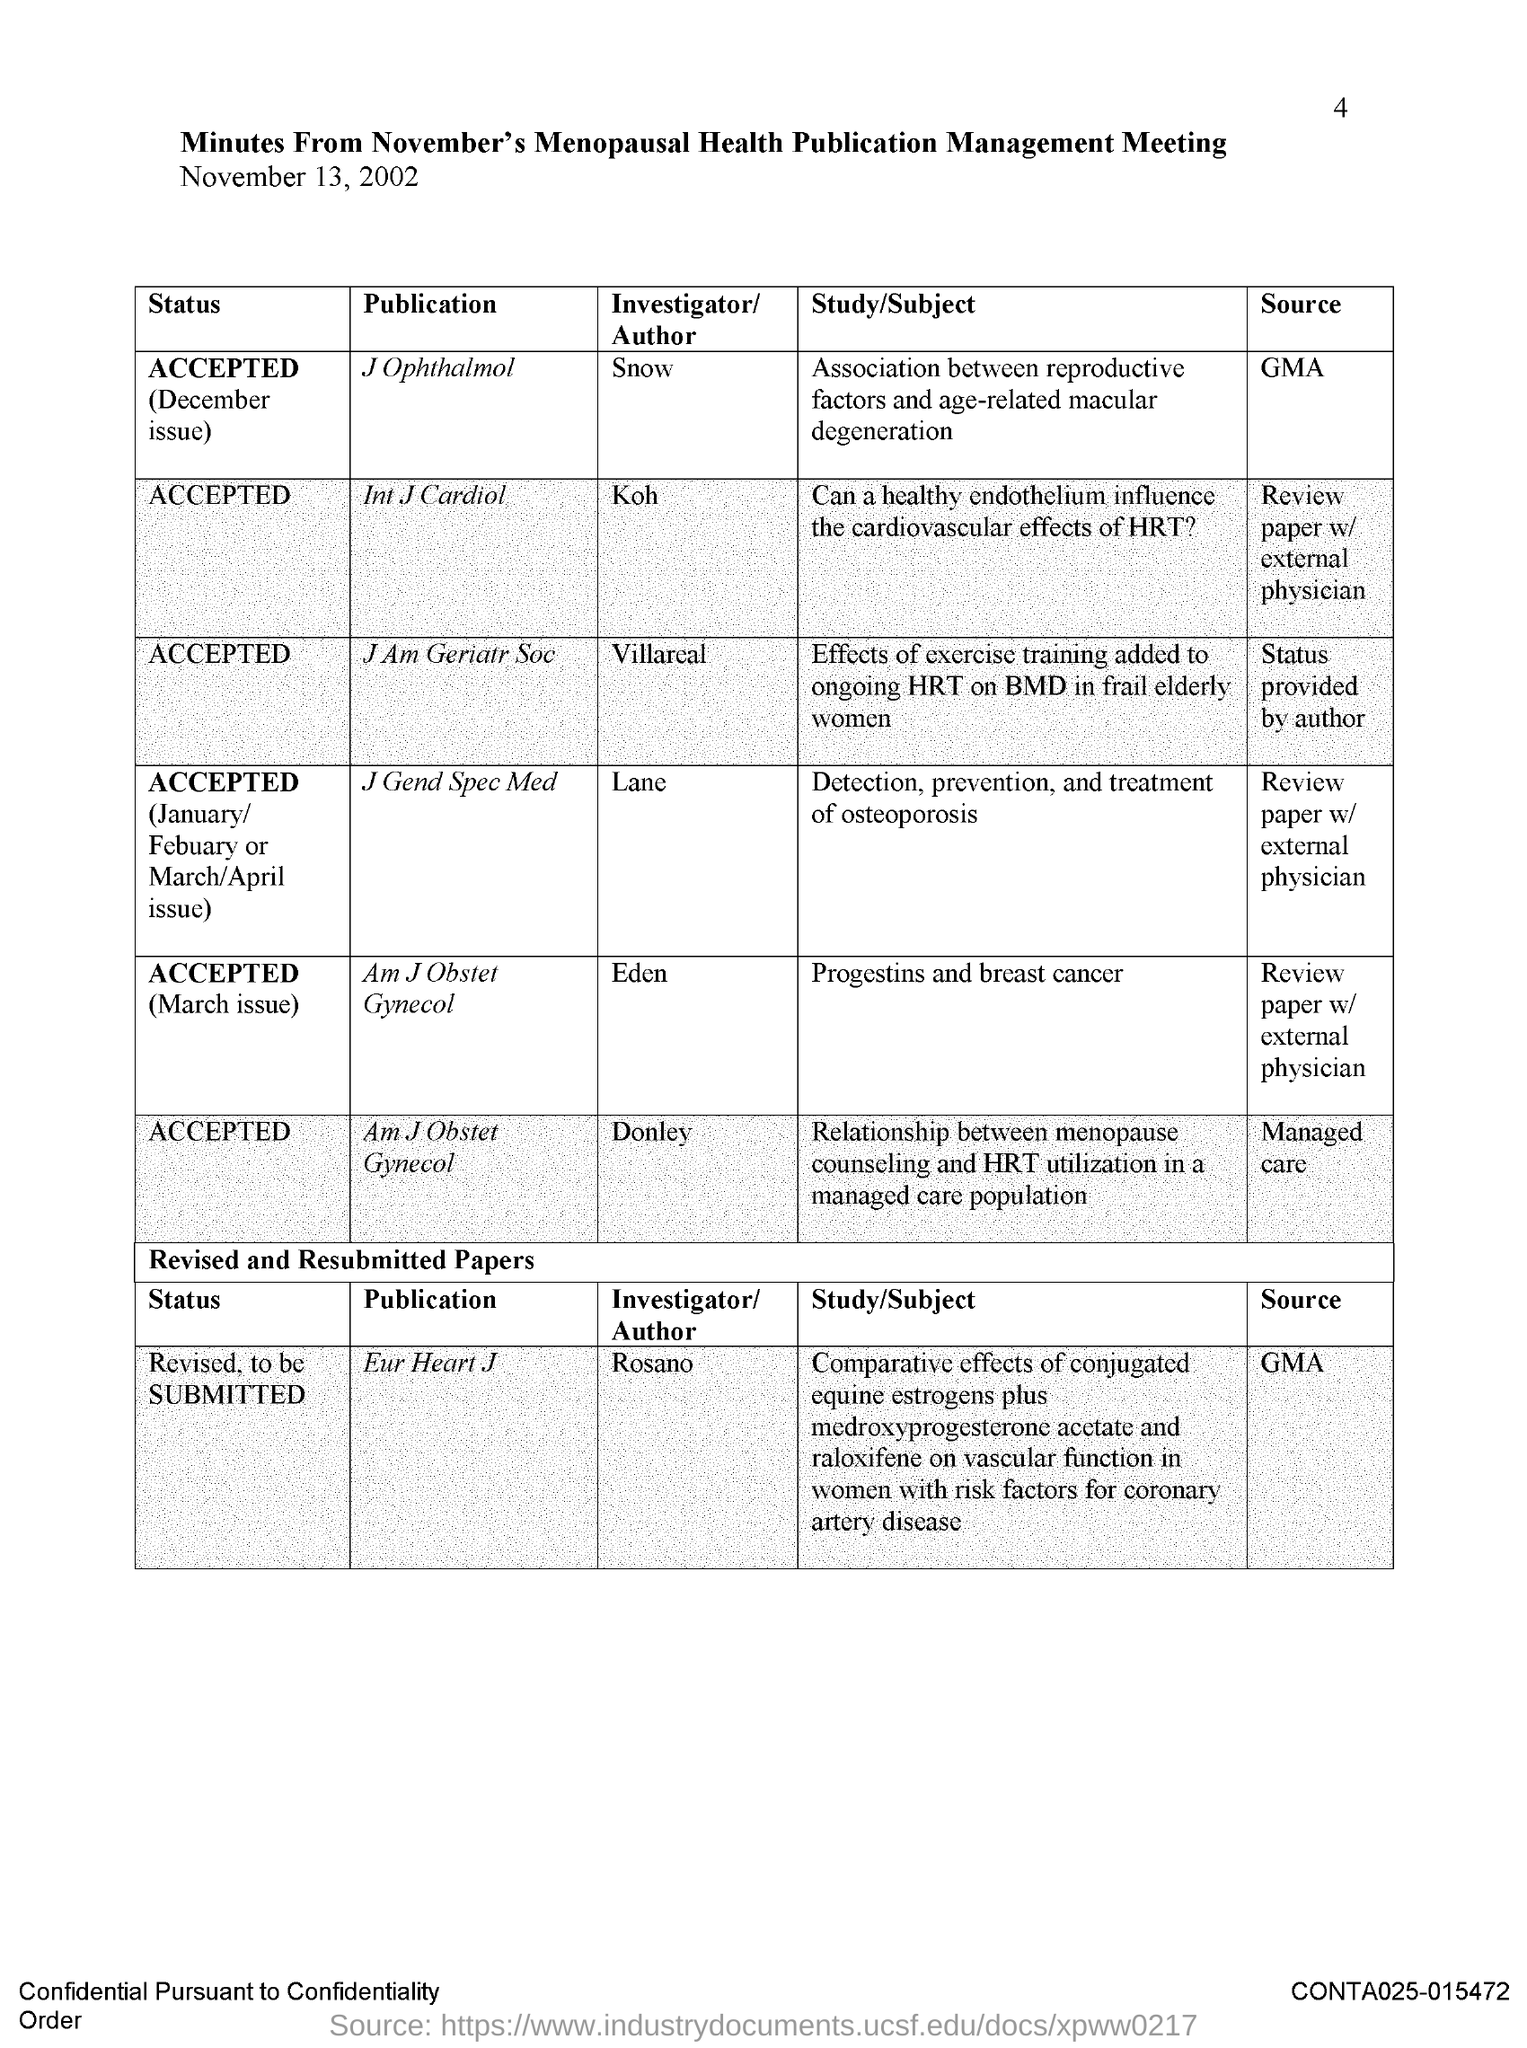What is the page number?
Give a very brief answer. 4. What is the title of the document?
Offer a very short reply. Minutes from november's menopausal health publication management meeting. What is the date mentioned in the document?
Keep it short and to the point. November 13, 2002. What is the status of the publication "Int J Cardiol"?
Offer a very short reply. Accepted. Who is the author of the publication "Eur Heart J"?
Your answer should be compact. Rosano. Who is the author of the publication "J Ophthalmol"?
Provide a short and direct response. Snow. 